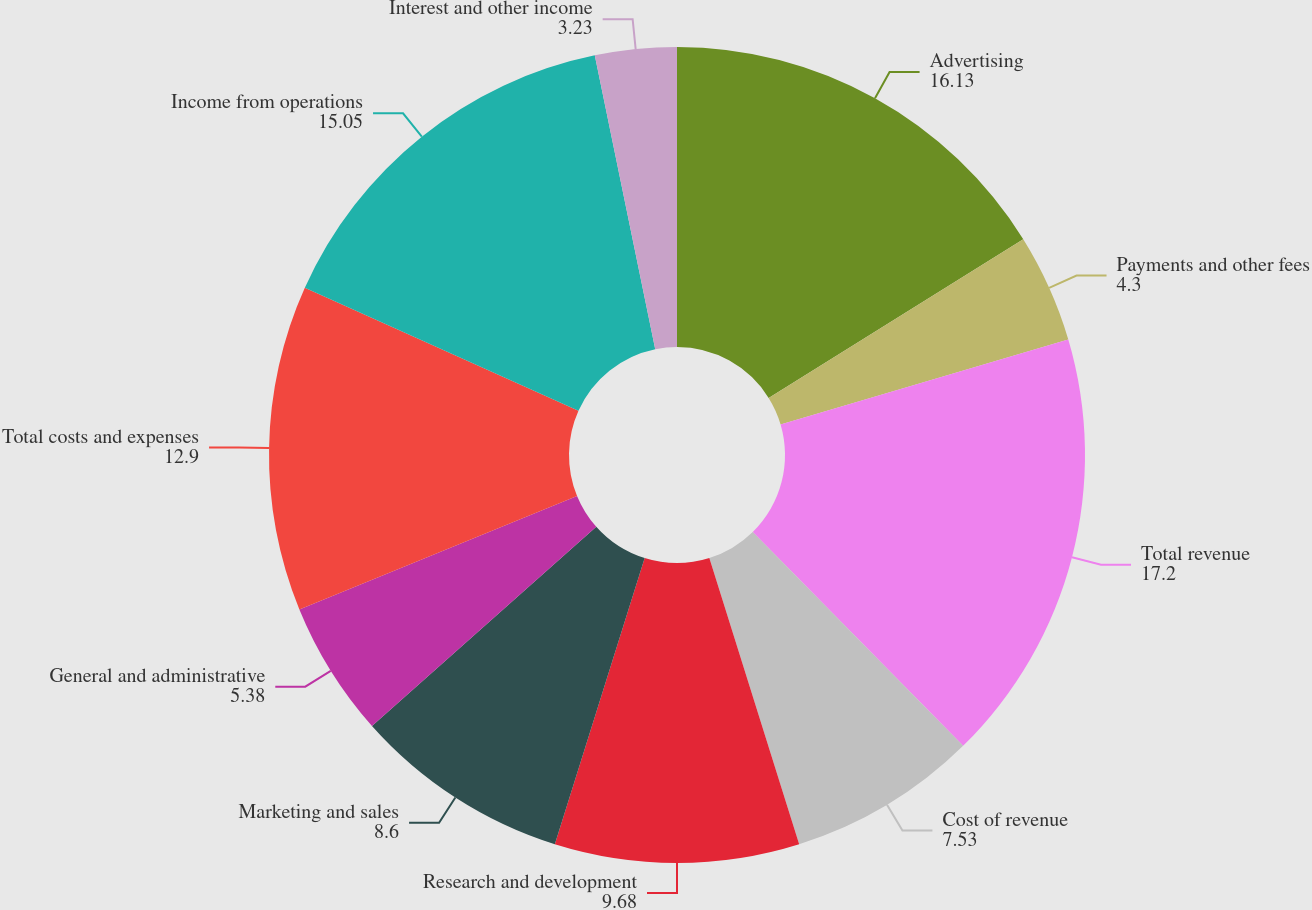Convert chart. <chart><loc_0><loc_0><loc_500><loc_500><pie_chart><fcel>Advertising<fcel>Payments and other fees<fcel>Total revenue<fcel>Cost of revenue<fcel>Research and development<fcel>Marketing and sales<fcel>General and administrative<fcel>Total costs and expenses<fcel>Income from operations<fcel>Interest and other income<nl><fcel>16.13%<fcel>4.3%<fcel>17.2%<fcel>7.53%<fcel>9.68%<fcel>8.6%<fcel>5.38%<fcel>12.9%<fcel>15.05%<fcel>3.23%<nl></chart> 